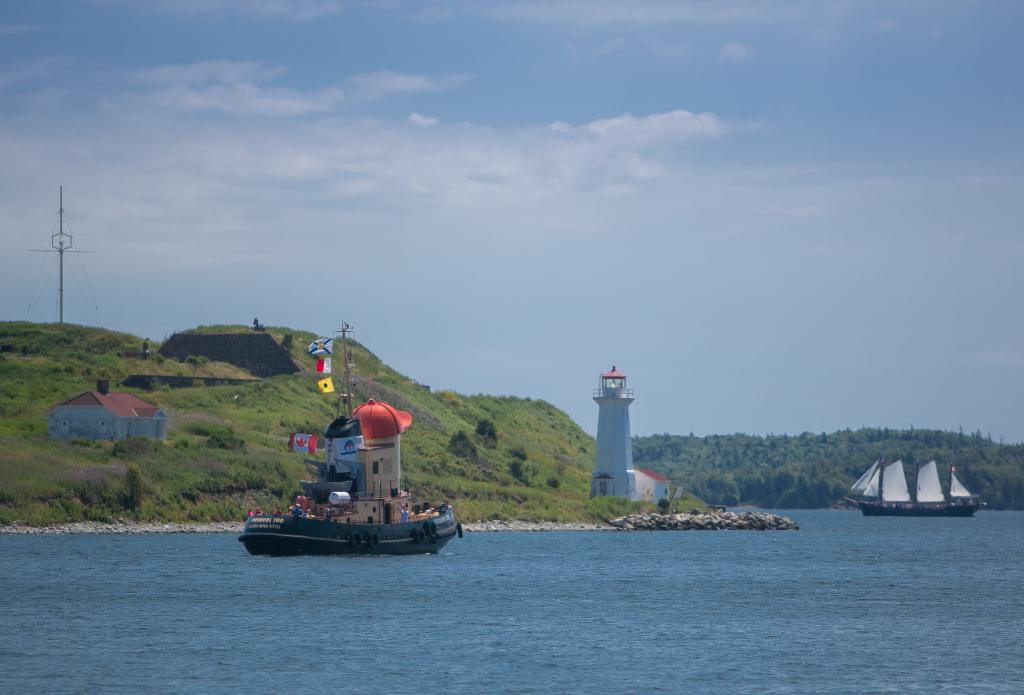What can be seen on the river in the image? There are boats on the river in the image. What is visible in the background of the image? There are mountains in the background of the image. What type of vegetation is present on the mountain? Trees are present on the mountain. What structures can be seen on the mountain? There is a house, a tower, and a pole on the mountain. What part of the natural environment is visible in the image? The sky is visible in the image. Can you tell me how many apples are hanging from the pole on the mountain? There are no apples present in the image; the pole is the only item mentioned on the mountain. What type of quiver is visible on the tower on the mountain? There is no quiver visible on the tower or any other structure in the image. 